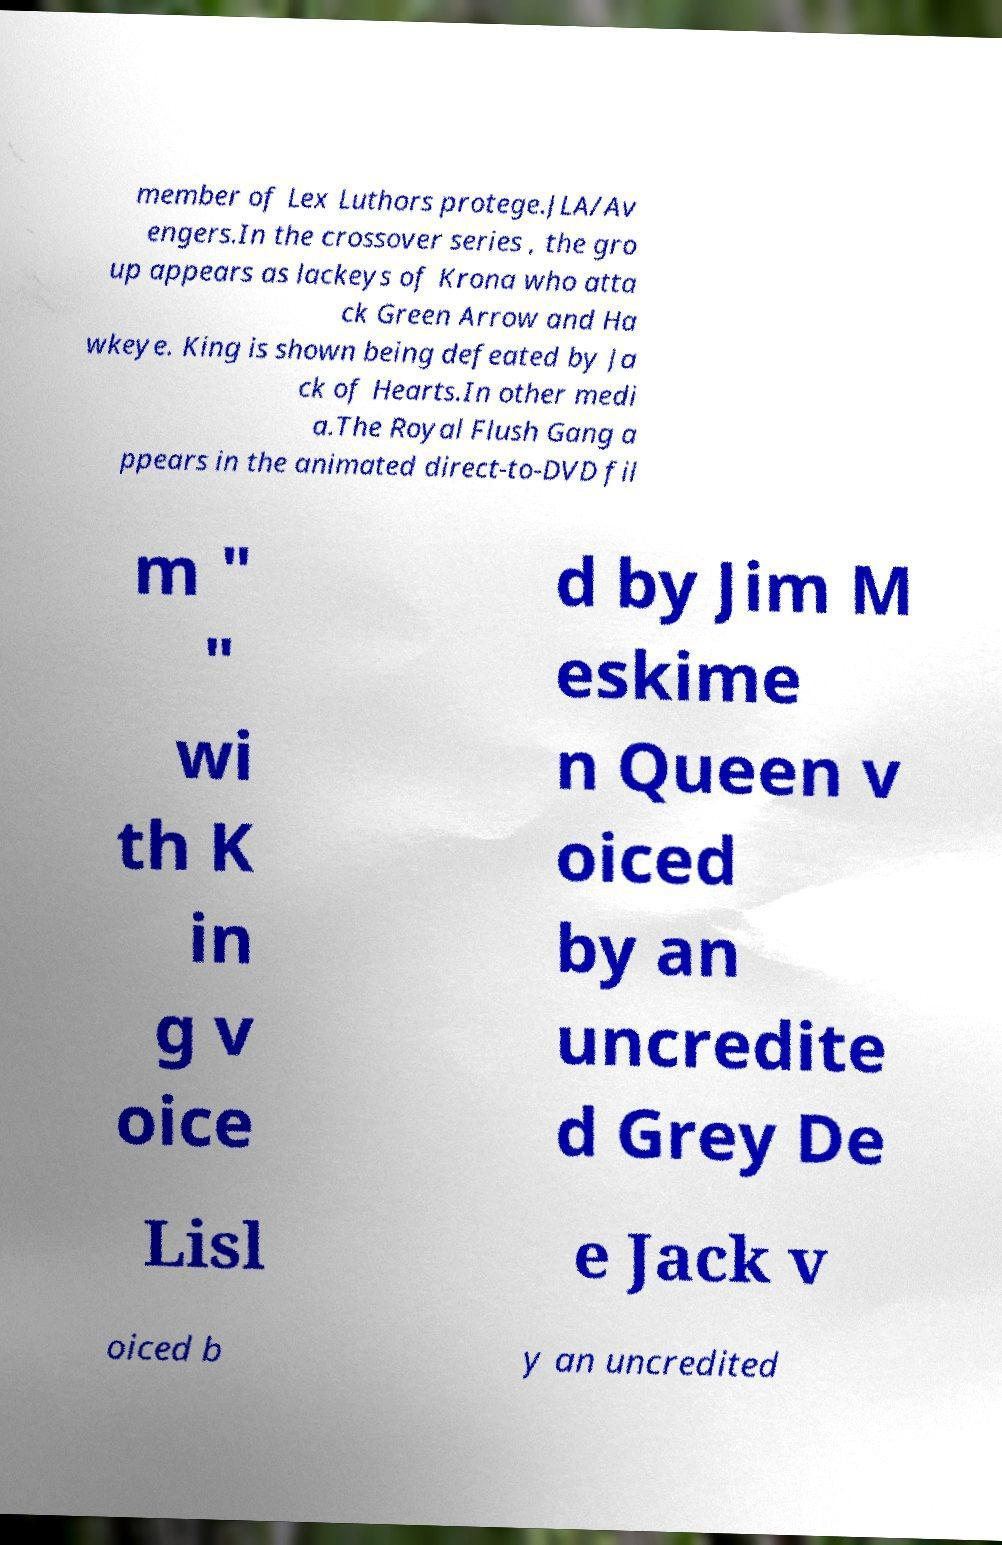Can you accurately transcribe the text from the provided image for me? member of Lex Luthors protege.JLA/Av engers.In the crossover series , the gro up appears as lackeys of Krona who atta ck Green Arrow and Ha wkeye. King is shown being defeated by Ja ck of Hearts.In other medi a.The Royal Flush Gang a ppears in the animated direct-to-DVD fil m " " wi th K in g v oice d by Jim M eskime n Queen v oiced by an uncredite d Grey De Lisl e Jack v oiced b y an uncredited 